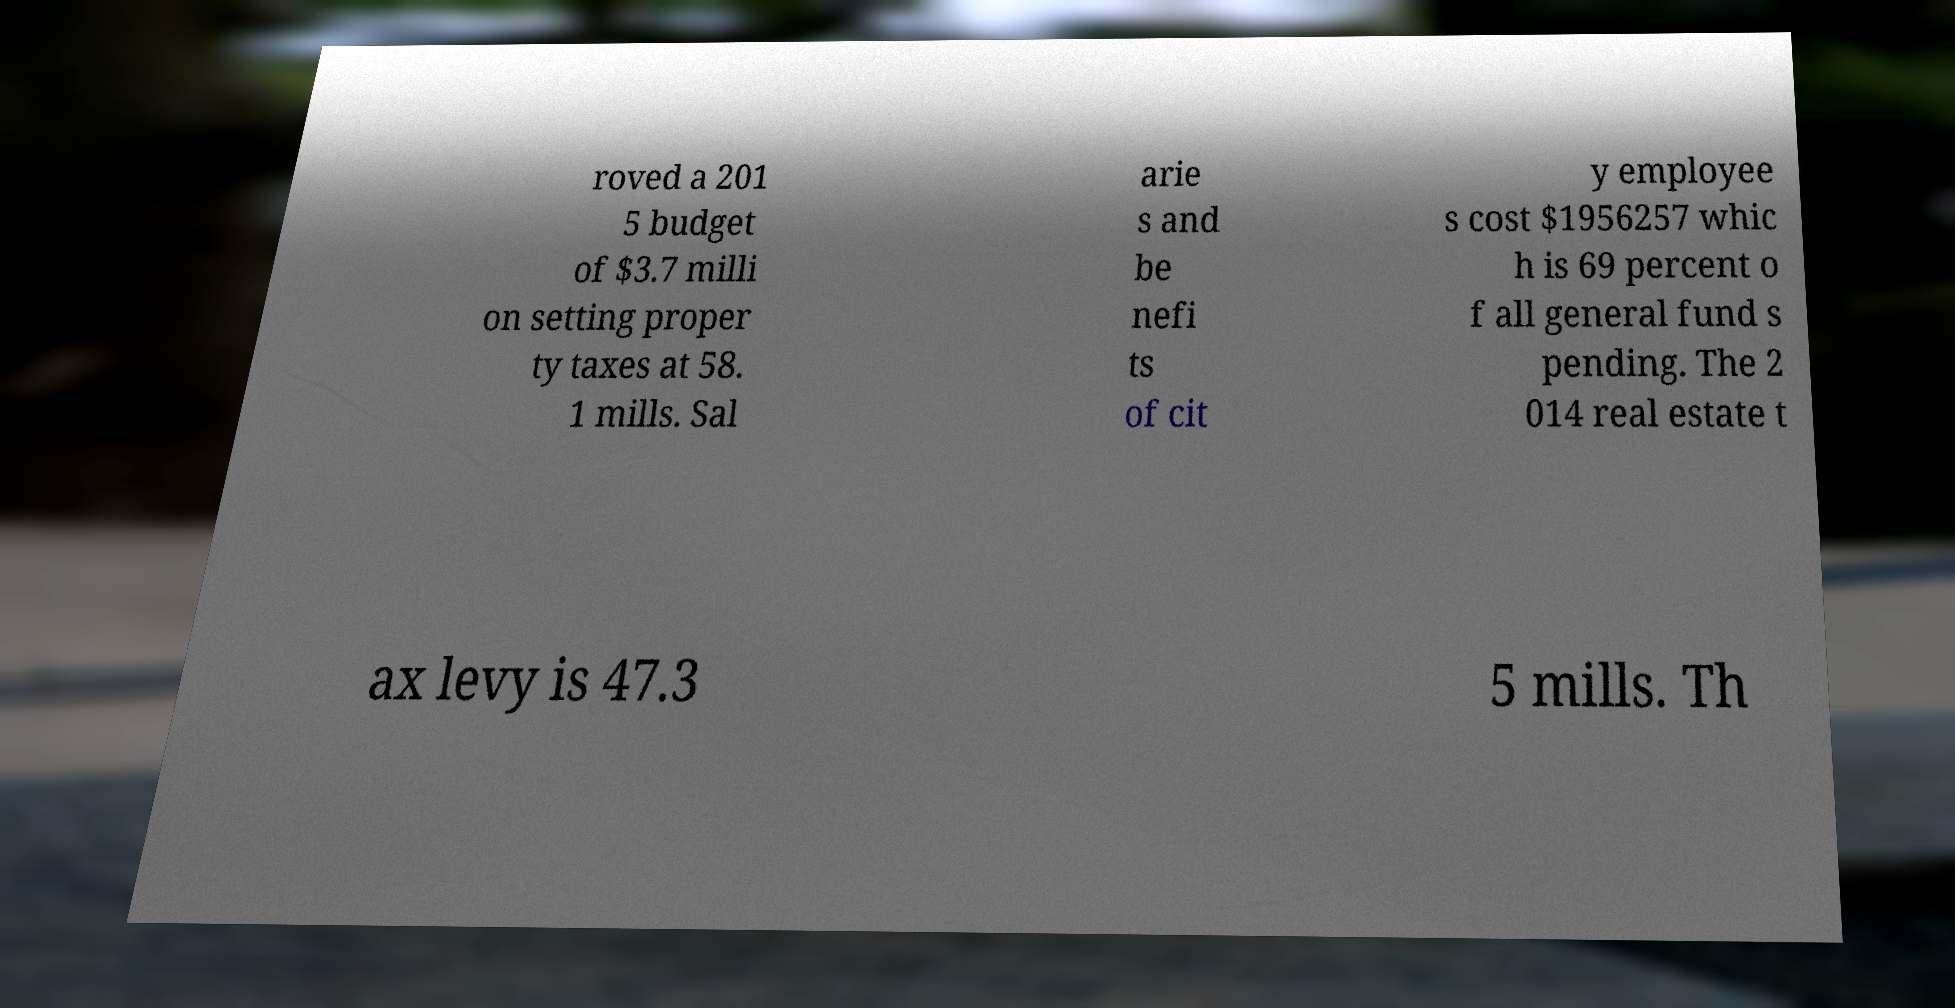For documentation purposes, I need the text within this image transcribed. Could you provide that? roved a 201 5 budget of $3.7 milli on setting proper ty taxes at 58. 1 mills. Sal arie s and be nefi ts of cit y employee s cost $1956257 whic h is 69 percent o f all general fund s pending. The 2 014 real estate t ax levy is 47.3 5 mills. Th 